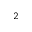Convert formula to latex. <formula><loc_0><loc_0><loc_500><loc_500>_ { 2 }</formula> 